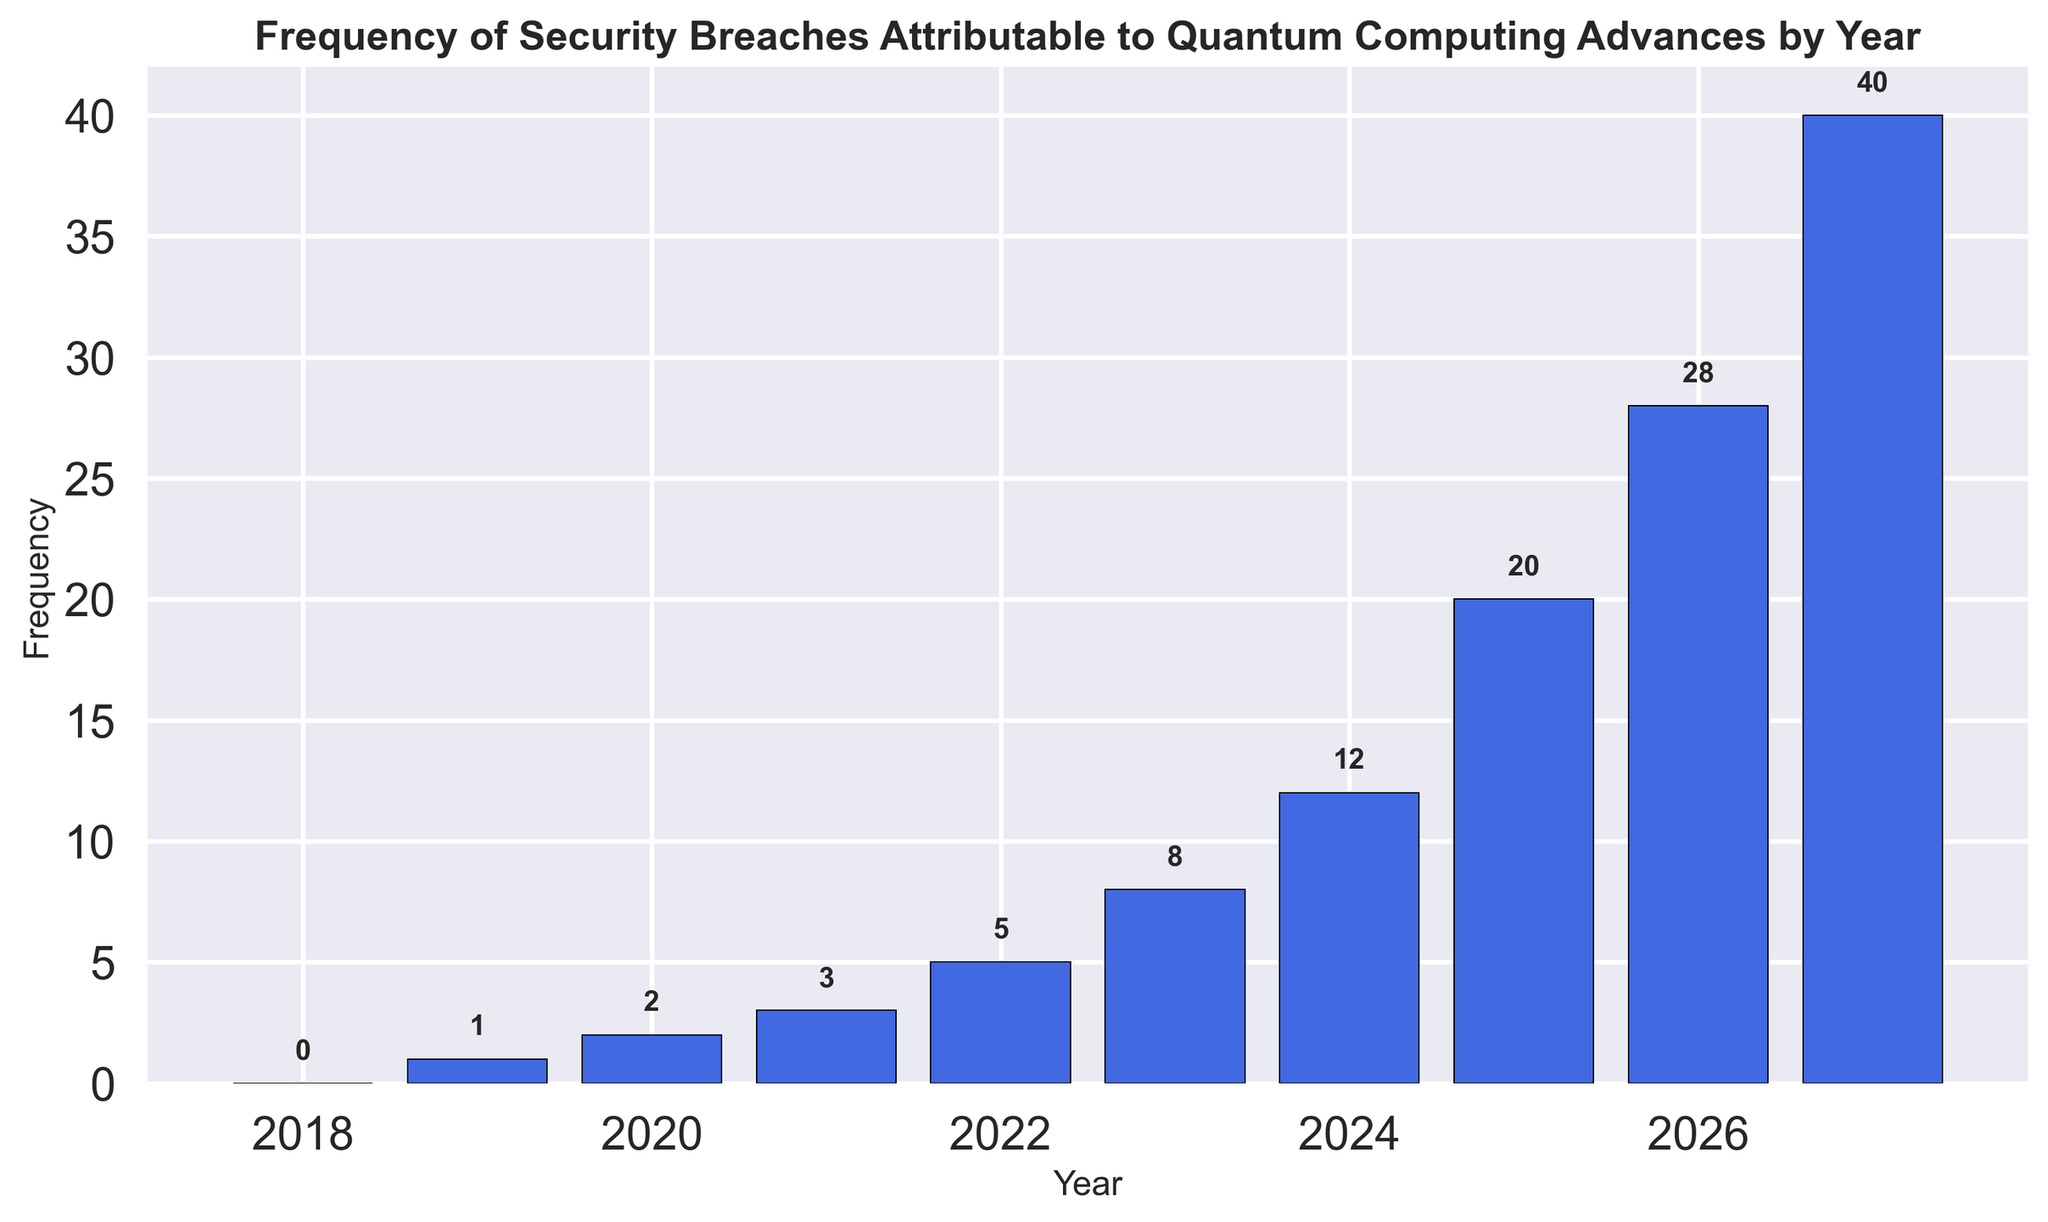How many security breaches were reported in 2025? Look at the height of the bar corresponding to the year 2025 on the x-axis. The labeled value on top of the bar is 20, which represents the frequency of breaches.
Answer: 20 Which year saw the first occurrence of security breaches attributed to quantum computing advances? The first bar with a value above 0 is for the year 2019. The height of the bar is 1, indicating 1 breach.
Answer: 2019 By how many breaches did the frequency increase from 2024 to 2025? The frequency in 2024 is 12 and in 2025 is 20. Subtract 12 from 20 to find the increase.
Answer: 8 What is the total number of breaches reported between 2022 and 2026, inclusive? Sum the frequencies of the years 2022 (5), 2023 (8), 2024 (12), 2025 (20), and 2026 (28). 5 + 8 + 12 + 20 + 28 = 73
Answer: 73 Which year experienced the highest number of security breaches? The year with the tallest bar is 2027, annotated with the value 40.
Answer: 2027 How does the breach frequency in 2023 compare to that in 2020? The frequency in 2023 is 8, and in 2020 it is 2. Since 8 is greater than 2, there were more breaches in 2023.
Answer: More in 2023 What's the average number of breaches per year from 2019 to 2021? Calculate the average by adding the frequencies for 2019 (1), 2020 (2), and 2021 (3), then divide by 3. (1 + 2 + 3)/3 = 2
Answer: 2 In which year does the number of breaches double compared to 2021? The frequency in 2021 is 3. Double that is 6. The frequency in 2023 is 8, which is more than double. The nearest year, 2022, has a frequency of 5, which is not double. There is no exact double, but 2023 is closest.
Answer: 2023 closest Describe the trend of security breaches over the years. The bar heights generally increase from left (earlier years) to right (later years). Early years show low values, then there is a rapid increase starting around 2024.
Answer: Increasing trend 